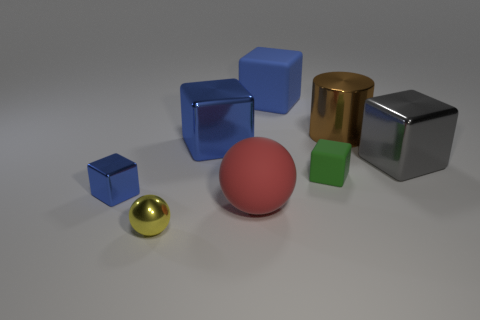What is the size of the shiny cube in front of the gray metal block?
Your answer should be compact. Small. How many rubber things are the same color as the rubber ball?
Make the answer very short. 0. There is a small object that is right of the small yellow object; are there any small metal things that are right of it?
Offer a very short reply. No. Is the color of the large thing behind the cylinder the same as the small metallic object that is behind the small metallic sphere?
Make the answer very short. Yes. What is the color of the shiny block that is the same size as the yellow metal ball?
Give a very brief answer. Blue. Is the number of blue metallic things behind the tiny matte object the same as the number of small metallic spheres behind the small sphere?
Give a very brief answer. No. There is a large blue cube that is to the right of the blue metallic thing behind the large gray thing; what is it made of?
Provide a short and direct response. Rubber. How many things are large red rubber balls or yellow matte objects?
Your response must be concise. 1. What size is the shiny thing that is the same color as the small shiny block?
Make the answer very short. Large. Are there fewer metallic balls than metal things?
Ensure brevity in your answer.  Yes. 